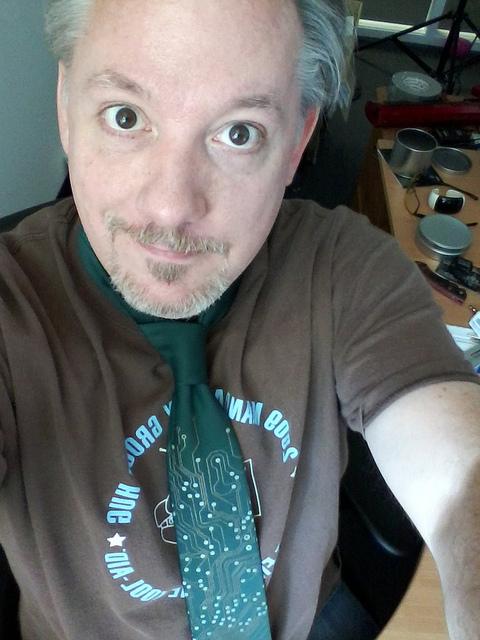Does the man have facial hair?
Be succinct. Yes. How is the man's hair styled?
Short answer required. Not. What body part is in the bottom right corner?
Short answer required. Arm. Is the tie real?
Concise answer only. Yes. IS this a fastidious man?
Write a very short answer. No. Why is he smiling?
Concise answer only. Happy. What is on the chair?
Be succinct. Man. What is on the man's shirt?
Short answer required. Tie. What color is his shirt?
Answer briefly. Brown. Does the pattern on the tie resemble an electronic circuit board?
Keep it brief. Yes. Is there something odd about the combination of clothes the man is wearing?
Short answer required. Yes. Is the man eating?
Answer briefly. No. 